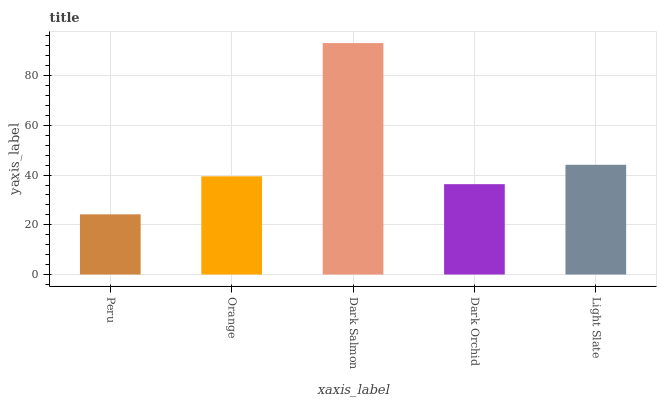Is Peru the minimum?
Answer yes or no. Yes. Is Dark Salmon the maximum?
Answer yes or no. Yes. Is Orange the minimum?
Answer yes or no. No. Is Orange the maximum?
Answer yes or no. No. Is Orange greater than Peru?
Answer yes or no. Yes. Is Peru less than Orange?
Answer yes or no. Yes. Is Peru greater than Orange?
Answer yes or no. No. Is Orange less than Peru?
Answer yes or no. No. Is Orange the high median?
Answer yes or no. Yes. Is Orange the low median?
Answer yes or no. Yes. Is Dark Salmon the high median?
Answer yes or no. No. Is Light Slate the low median?
Answer yes or no. No. 